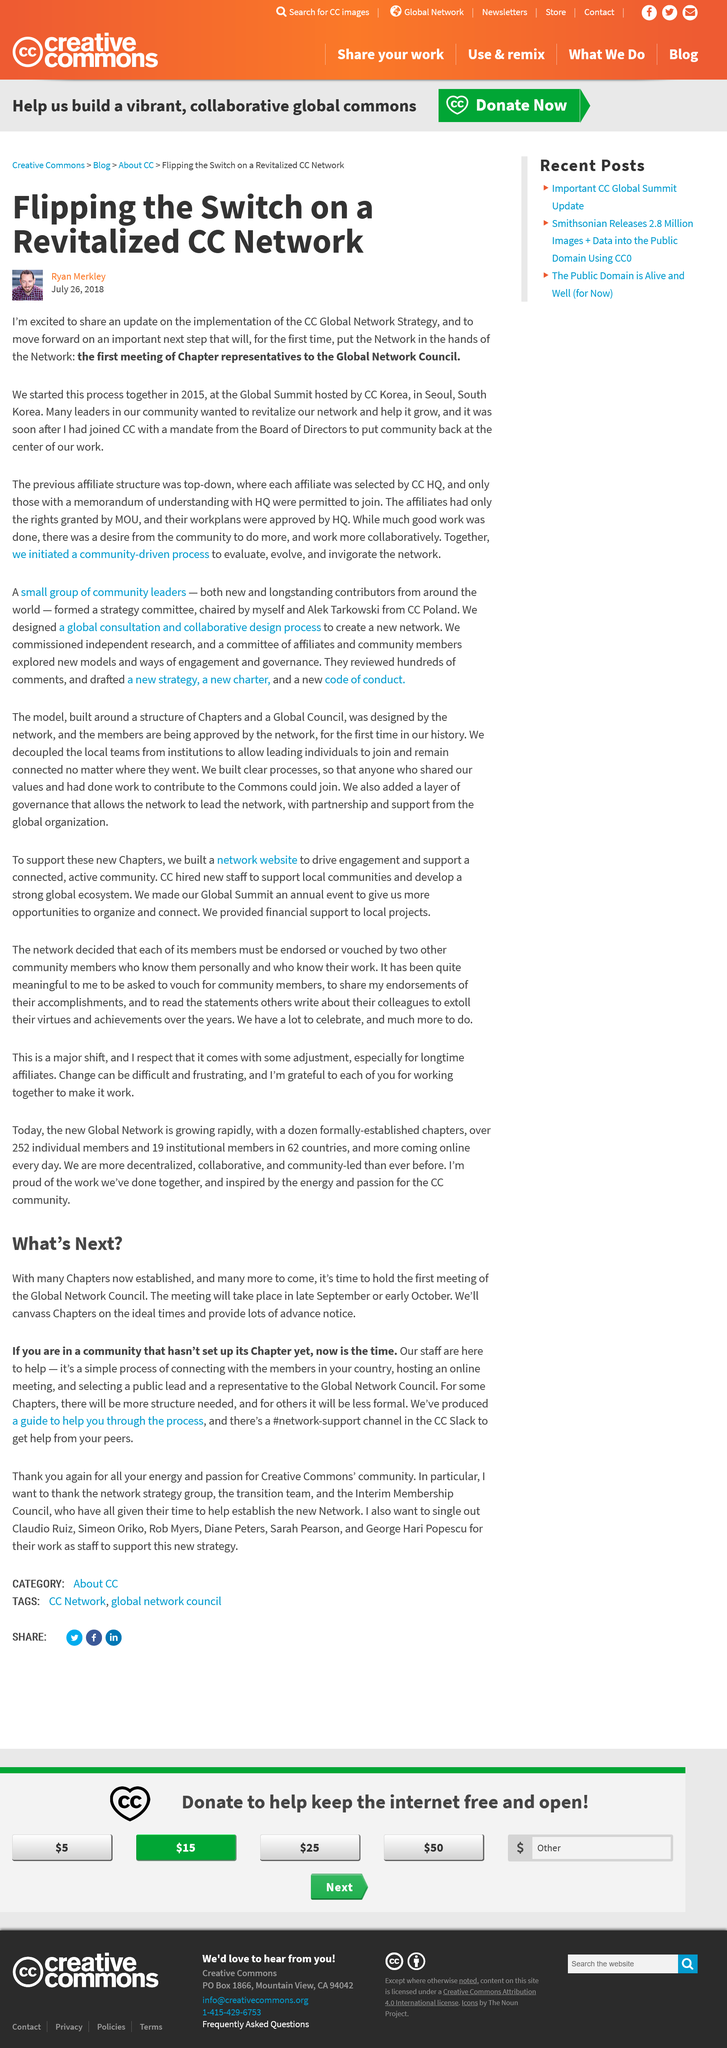Indicate a few pertinent items in this graphic. The Global Network Council's first meeting will occur in late September or early October. The man in the photo is named Ryan Merkley. The CC Slack offers a #network-support channel for members to receive assistance from their peers in setting up a Chapter. The title of the article is "Flipping the Switch on a Revitalized CC Network," which discusses the restoration and modernization of a computer communication network. The article was published on July 26th, 2018. 